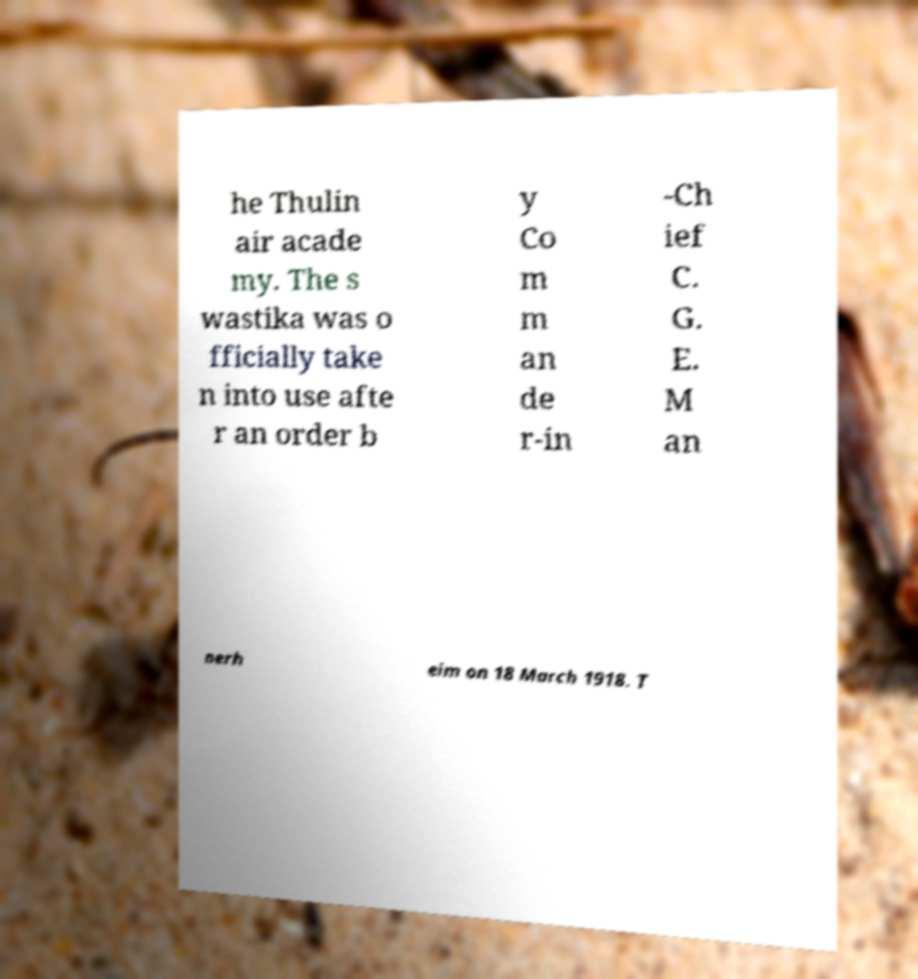Could you assist in decoding the text presented in this image and type it out clearly? he Thulin air acade my. The s wastika was o fficially take n into use afte r an order b y Co m m an de r-in -Ch ief C. G. E. M an nerh eim on 18 March 1918. T 